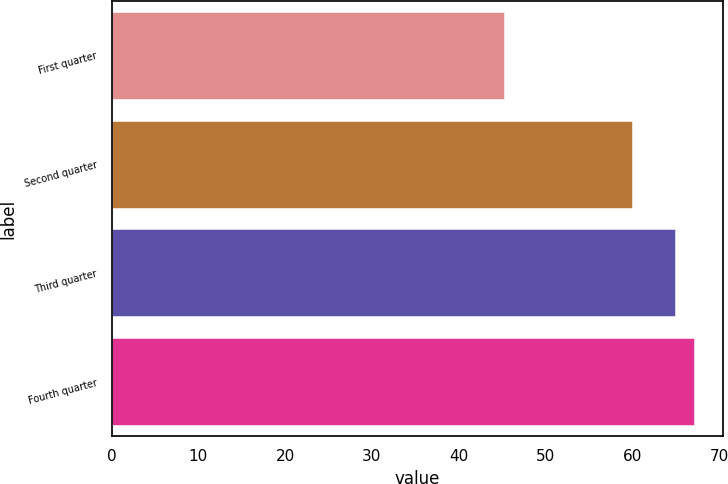Convert chart to OTSL. <chart><loc_0><loc_0><loc_500><loc_500><bar_chart><fcel>First quarter<fcel>Second quarter<fcel>Third quarter<fcel>Fourth quarter<nl><fcel>45.27<fcel>59.95<fcel>64.98<fcel>67.15<nl></chart> 